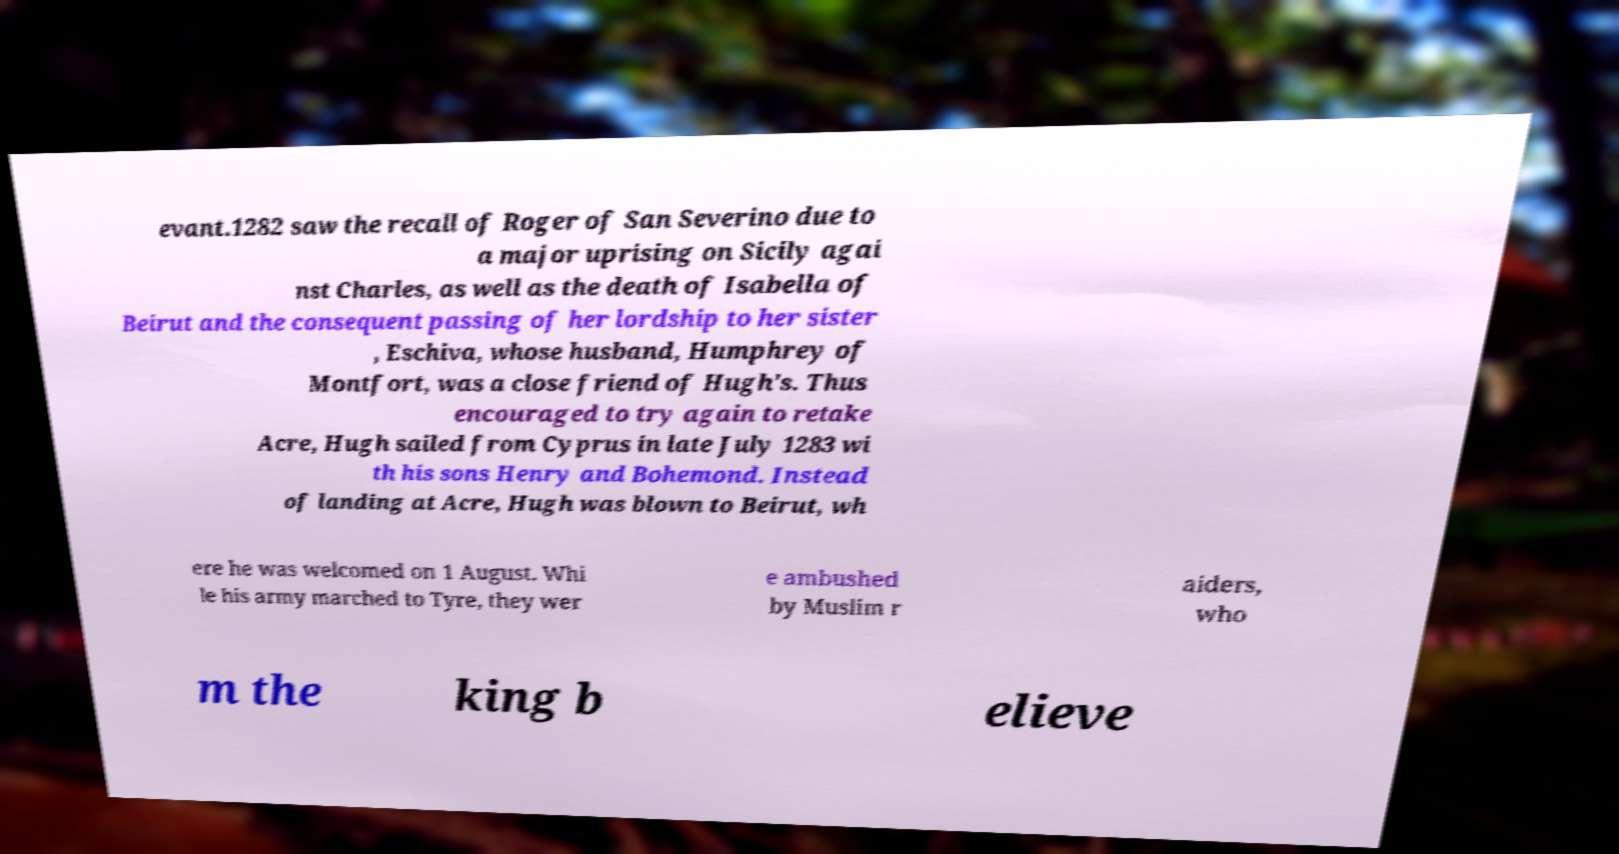Could you assist in decoding the text presented in this image and type it out clearly? evant.1282 saw the recall of Roger of San Severino due to a major uprising on Sicily agai nst Charles, as well as the death of Isabella of Beirut and the consequent passing of her lordship to her sister , Eschiva, whose husband, Humphrey of Montfort, was a close friend of Hugh's. Thus encouraged to try again to retake Acre, Hugh sailed from Cyprus in late July 1283 wi th his sons Henry and Bohemond. Instead of landing at Acre, Hugh was blown to Beirut, wh ere he was welcomed on 1 August. Whi le his army marched to Tyre, they wer e ambushed by Muslim r aiders, who m the king b elieve 